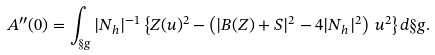Convert formula to latex. <formula><loc_0><loc_0><loc_500><loc_500>A ^ { \prime \prime } ( 0 ) = \int _ { \S g } | N _ { h } | ^ { - 1 } \left \{ Z ( u ) ^ { 2 } - \left ( | B ( Z ) + S | ^ { 2 } - 4 | N _ { h } | ^ { 2 } \right ) \, u ^ { 2 } \right \} d \S g .</formula> 